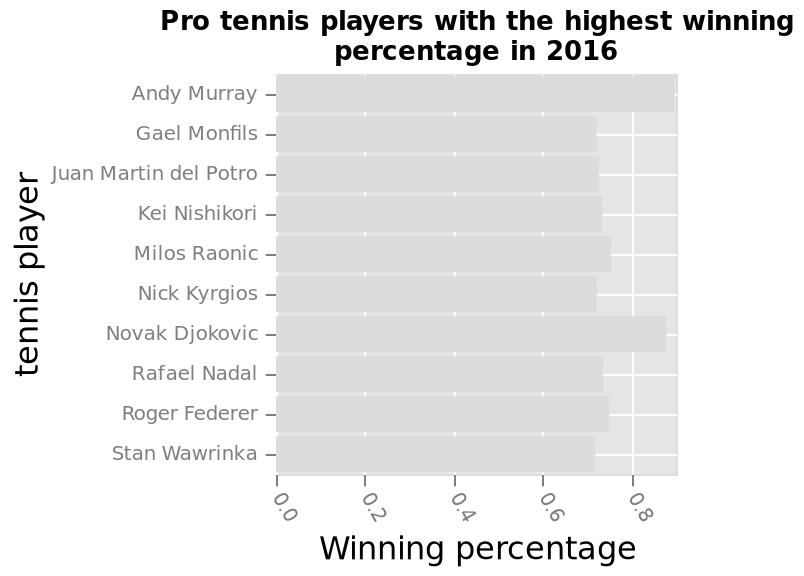<image>
Describe the following image in detail Pro tennis players with the highest winning percentage in 2016 is a bar chart. The x-axis measures Winning percentage while the y-axis measures tennis player. What does the x-axis measure in the bar chart?  The x-axis measures winning percentage in the bar chart. 